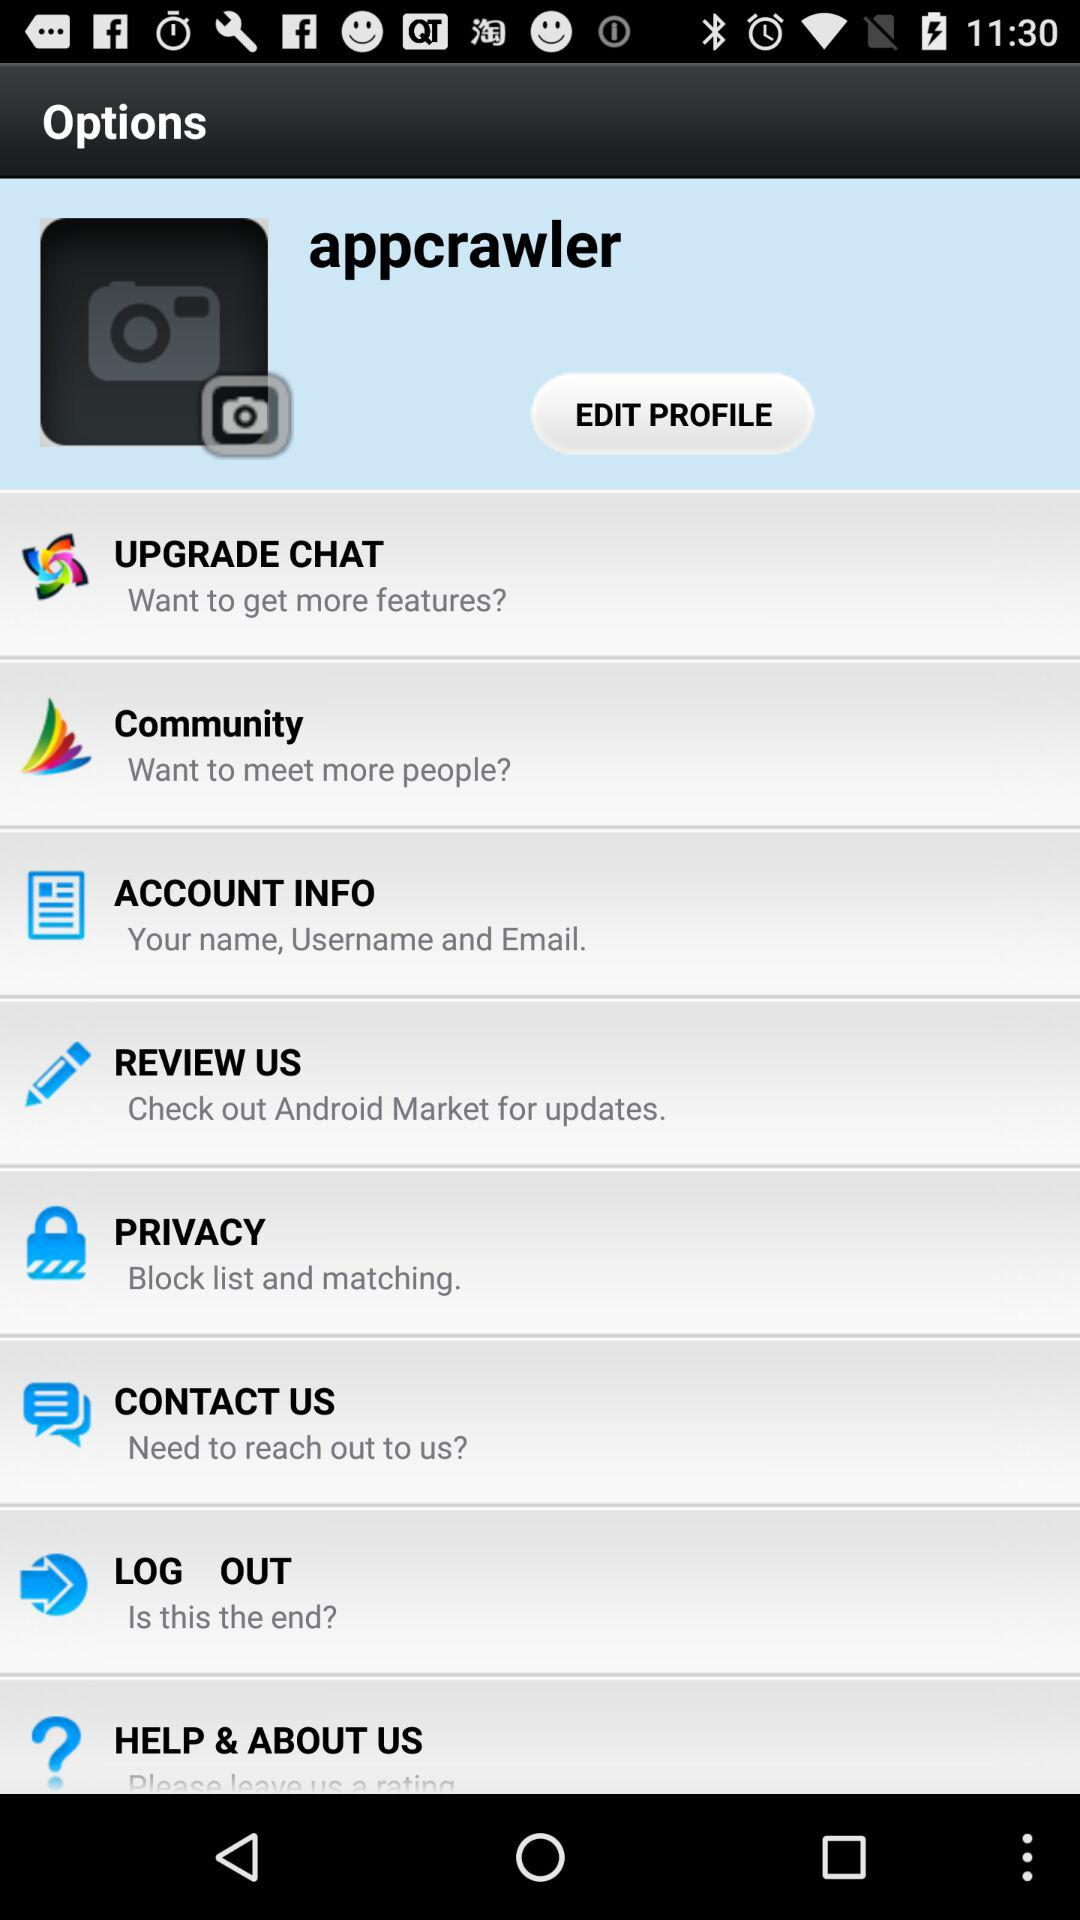What's the user profile name? The user profile name is Appcrawler. 